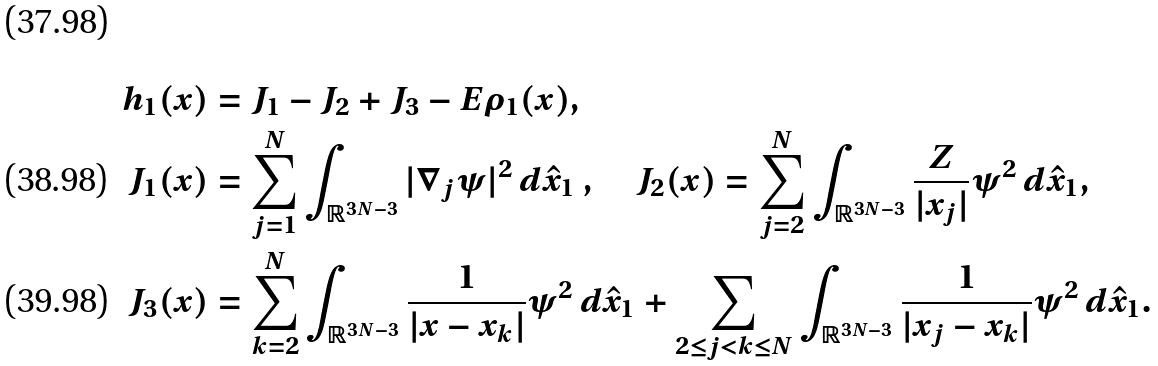<formula> <loc_0><loc_0><loc_500><loc_500>h _ { 1 } ( x ) & = J _ { 1 } - J _ { 2 } + J _ { 3 } - E \rho _ { 1 } ( x ) , \\ J _ { 1 } ( x ) & = \sum _ { j = 1 } ^ { N } \int _ { { \mathbb { R } } ^ { 3 N - 3 } } | \nabla _ { j } \psi | ^ { 2 } \, d \hat { x } _ { 1 } \ , \quad J _ { 2 } ( x ) = \sum _ { j = 2 } ^ { N } \int _ { { \mathbb { R } } ^ { 3 N - 3 } } \frac { Z } { | x _ { j } | } \psi ^ { 2 } \, d \hat { x } _ { 1 } , \\ J _ { 3 } ( x ) & = \sum _ { k = 2 } ^ { N } \int _ { { \mathbb { R } } ^ { 3 N - 3 } } \frac { 1 } { | x - x _ { k } | } \psi ^ { 2 } \, d \hat { x } _ { 1 } + \sum _ { 2 \leq j < k \leq N } \int _ { { \mathbb { R } } ^ { 3 N - 3 } } \frac { 1 } { | x _ { j } - x _ { k } | } \psi ^ { 2 } \, d \hat { x } _ { 1 } .</formula> 